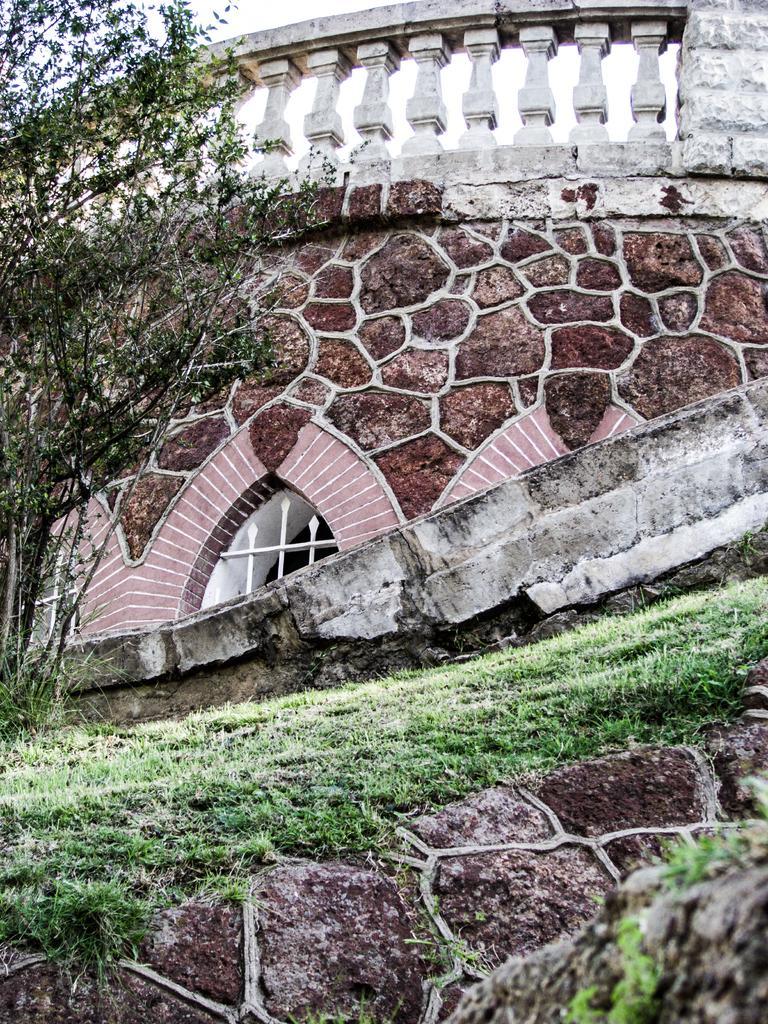In one or two sentences, can you explain what this image depicts? In this image I can see on the left side there are trees, in the middle it is the construction. At the bottom there is the grass. 